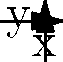Given the polar coordinate plot of classified intelligence locations A, B, C, D, and E, which location is positioned at $(0°, 1)$ and what is the angular difference between locations B and D? To solve this question, let's analyze the given polar coordinate plot step-by-step:

1. Identify the location at $(0°, 1)$:
   - Point A is located on the positive x-axis (0°) at a distance of 1 unit from the origin.
   - Therefore, A is positioned at $(0°, 1)$.

2. Find the angular positions of B and D:
   - B appears to be in the first quadrant, at a 45° angle.
   - D is on the negative x-axis, which corresponds to a 180° angle.

3. Calculate the angular difference between B and D:
   - Angular difference = $|180° - 45°| = 135°$

The question asks for two pieces of information:
1. The location positioned at $(0°, 1)$, which is A.
2. The angular difference between B and D, which is 135°.
Answer: A, 135° 